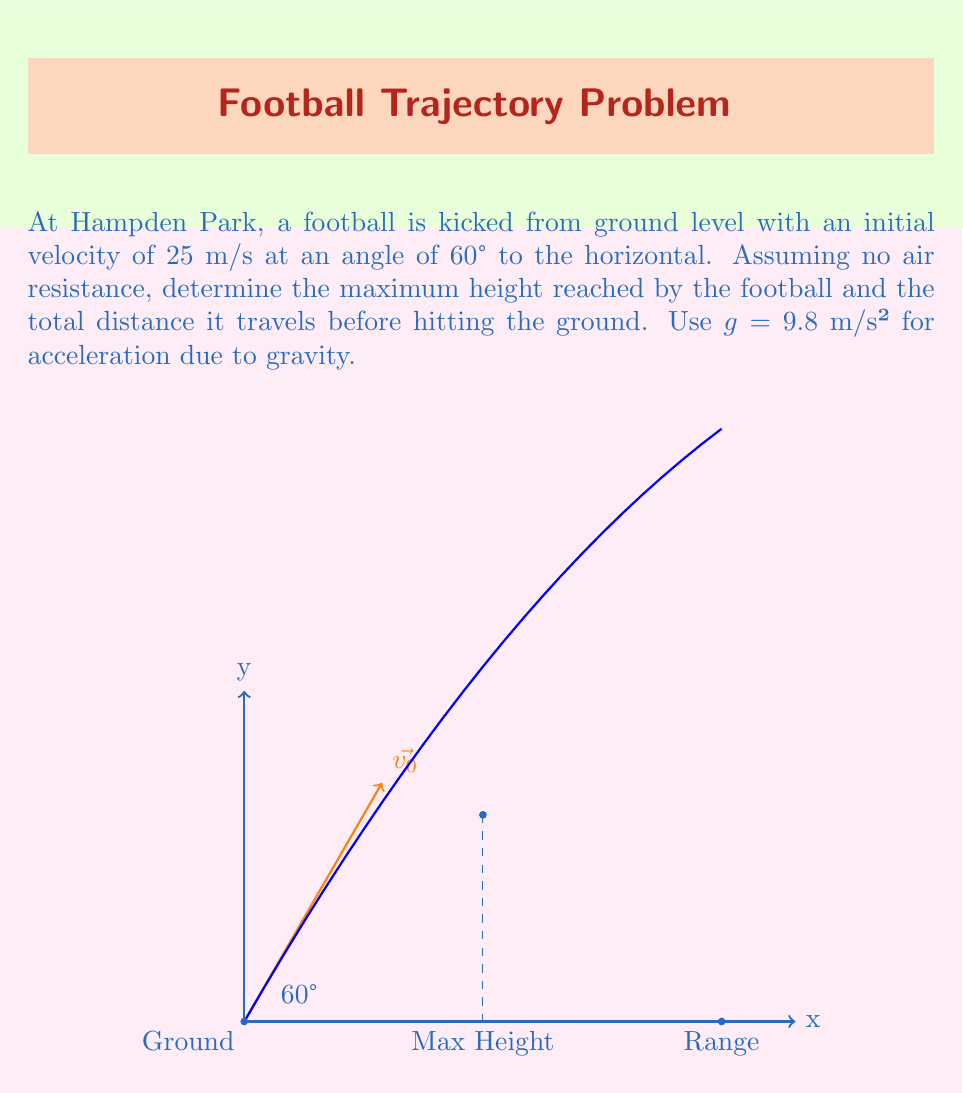Provide a solution to this math problem. Let's solve this step-by-step using the equations of motion for projectile motion:

1) First, let's break down the initial velocity into its x and y components:
   $$v_{0x} = v_0 \cos(\theta) = 25 \cos(60°) = 12.5 \text{ m/s}$$
   $$v_{0y} = v_0 \sin(\theta) = 25 \sin(60°) = 21.65 \text{ m/s}$$

2) To find the maximum height, we use the equation:
   $$y_{max} = \frac{v_{0y}^2}{2g}$$
   $$y_{max} = \frac{(21.65)^2}{2(9.8)} = 23.93 \text{ m}$$

3) To find the total distance (range), we use the equation:
   $$R = \frac{v_0^2 \sin(2\theta)}{g}$$
   $$R = \frac{25^2 \sin(120°)}{9.8} = 55.11 \text{ m}$$

4) We can verify this using the time of flight:
   $$t_{total} = \frac{2v_{0y}}{g} = \frac{2(21.65)}{9.8} = 4.42 \text{ s}$$
   $$R = v_{0x} \cdot t_{total} = 12.5 \cdot 4.42 = 55.25 \text{ m}$$
   (The small difference is due to rounding)
Answer: Maximum height: 23.93 m, Range: 55.11 m 